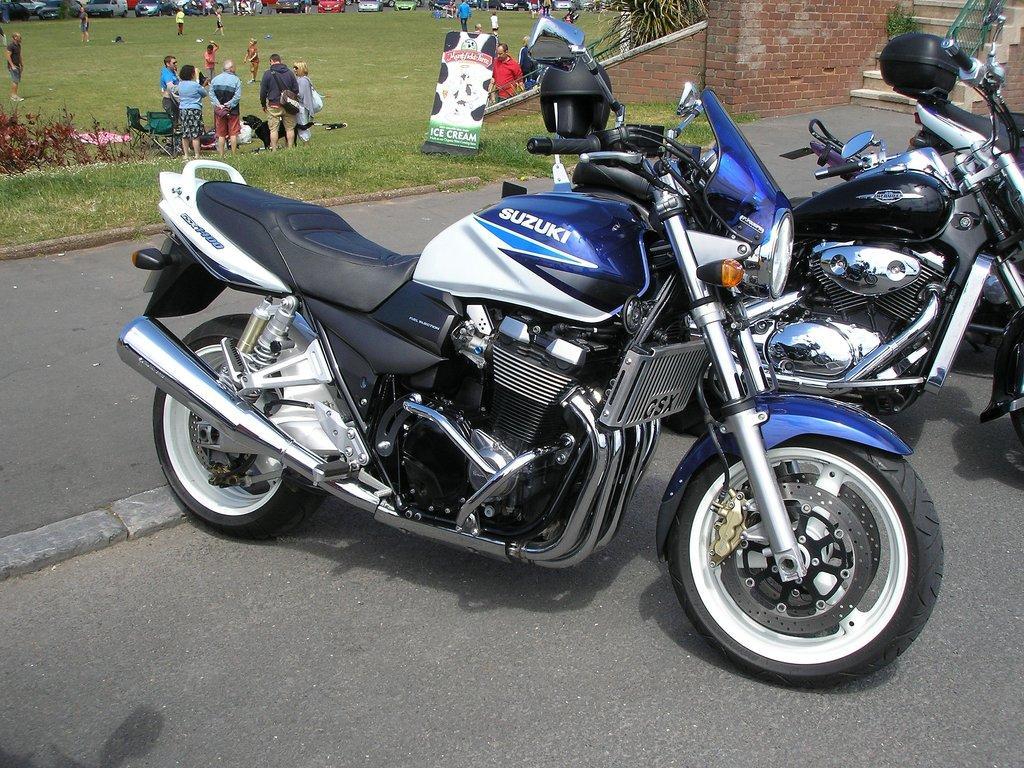Please provide a concise description of this image. In front of the picture, we see the bikes parked on the road. At the bottom, we see the road. In the middle, we see the people are standing. Beside them, we see a wall which is made up of brown colored bricks. On the left side, we see the grass, plants and the people are standing. Beside them, we see a black dog. In the background, we see the cars and the trees. In the right top, we see the staircase. 